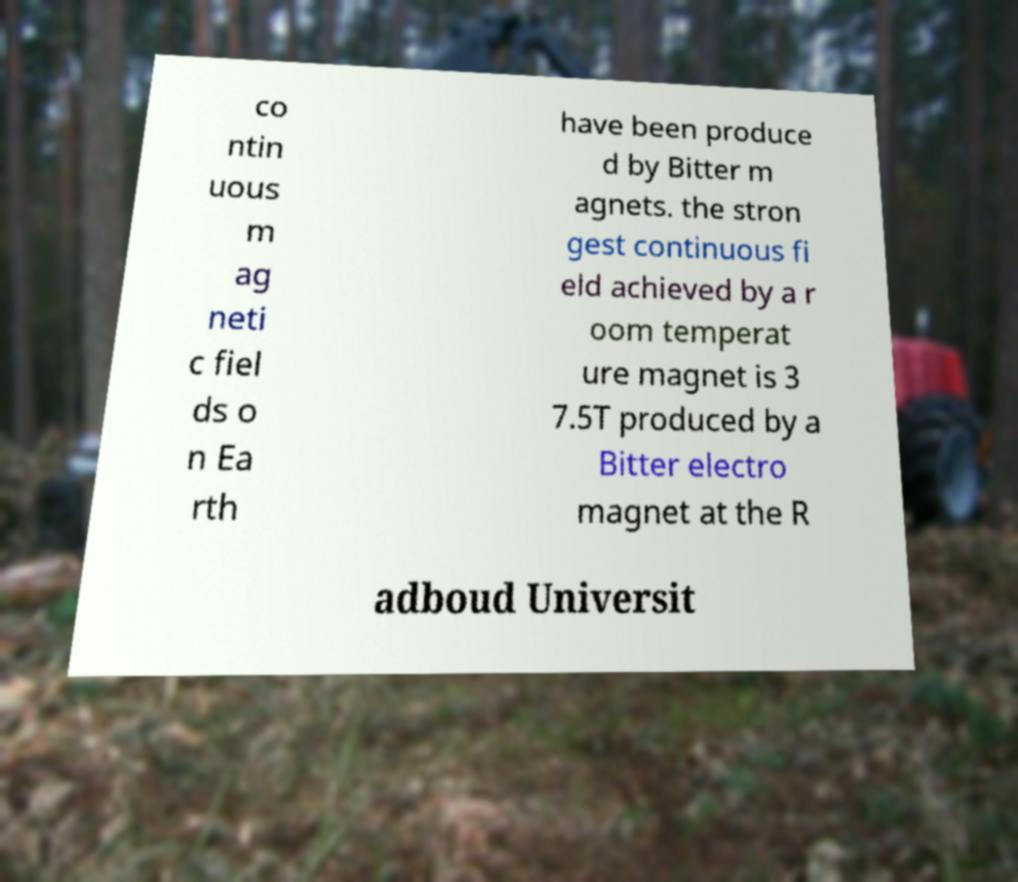What messages or text are displayed in this image? I need them in a readable, typed format. co ntin uous m ag neti c fiel ds o n Ea rth have been produce d by Bitter m agnets. the stron gest continuous fi eld achieved by a r oom temperat ure magnet is 3 7.5T produced by a Bitter electro magnet at the R adboud Universit 